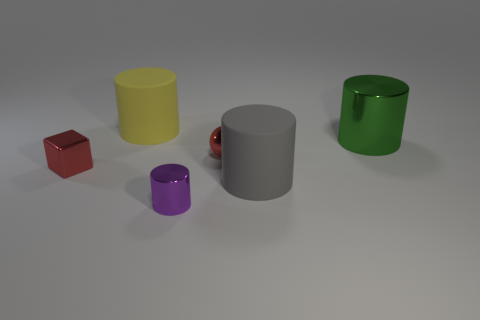What size is the gray cylinder?
Give a very brief answer. Large. Is the color of the tiny object on the left side of the yellow cylinder the same as the shiny ball?
Make the answer very short. Yes. Are there more matte cylinders right of the tiny purple metallic cylinder than tiny things left of the tiny red block?
Your response must be concise. Yes. Are there more green objects than cyan balls?
Make the answer very short. Yes. There is a thing that is both right of the small shiny sphere and behind the big gray matte cylinder; what is its size?
Provide a short and direct response. Large. What shape is the green thing?
Your response must be concise. Cylinder. Is the number of small metallic things behind the small purple cylinder greater than the number of tiny gray matte spheres?
Your answer should be very brief. Yes. There is a thing that is in front of the rubber thing that is in front of the big cylinder left of the gray rubber cylinder; what is its shape?
Your answer should be very brief. Cylinder. Is the size of the red object right of the yellow rubber thing the same as the tiny purple metal cylinder?
Ensure brevity in your answer.  Yes. There is a thing that is both right of the tiny red shiny ball and behind the red ball; what shape is it?
Keep it short and to the point. Cylinder. 